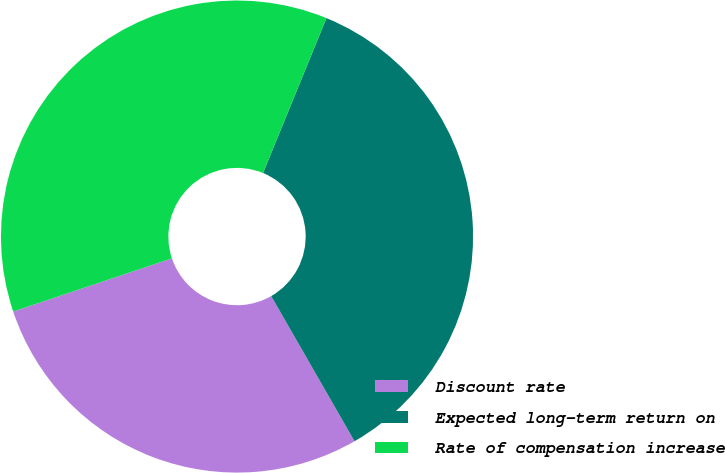Convert chart to OTSL. <chart><loc_0><loc_0><loc_500><loc_500><pie_chart><fcel>Discount rate<fcel>Expected long-term return on<fcel>Rate of compensation increase<nl><fcel>28.15%<fcel>35.52%<fcel>36.33%<nl></chart> 